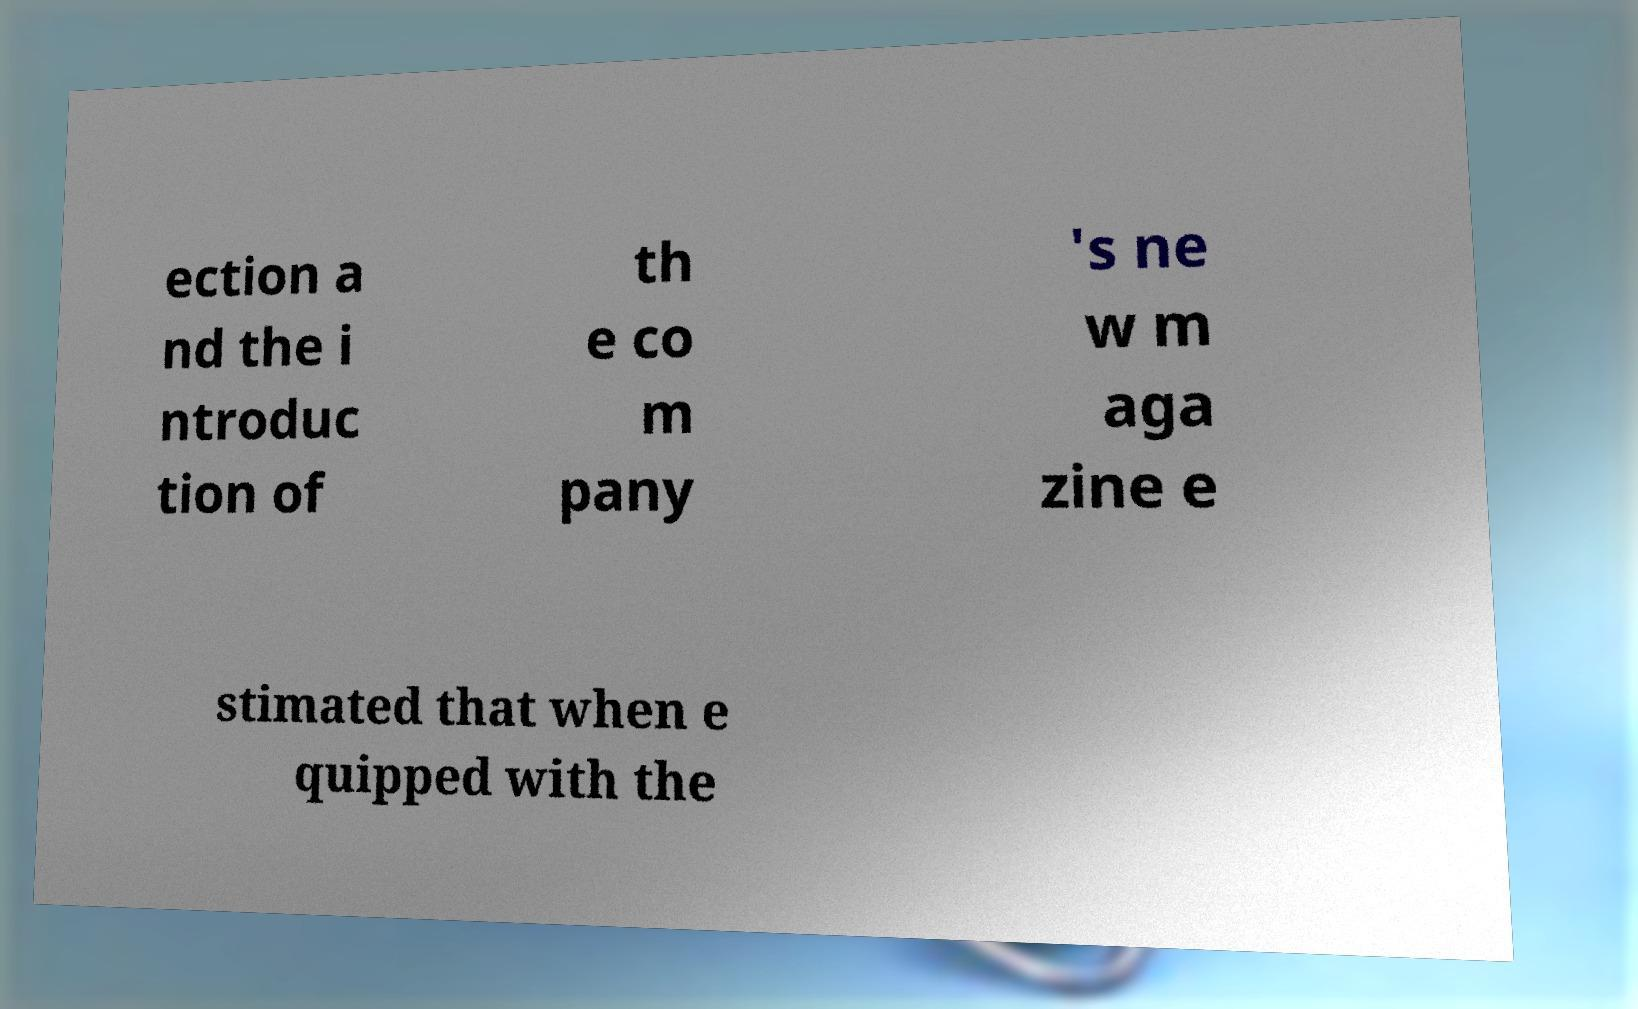What messages or text are displayed in this image? I need them in a readable, typed format. ection a nd the i ntroduc tion of th e co m pany 's ne w m aga zine e stimated that when e quipped with the 